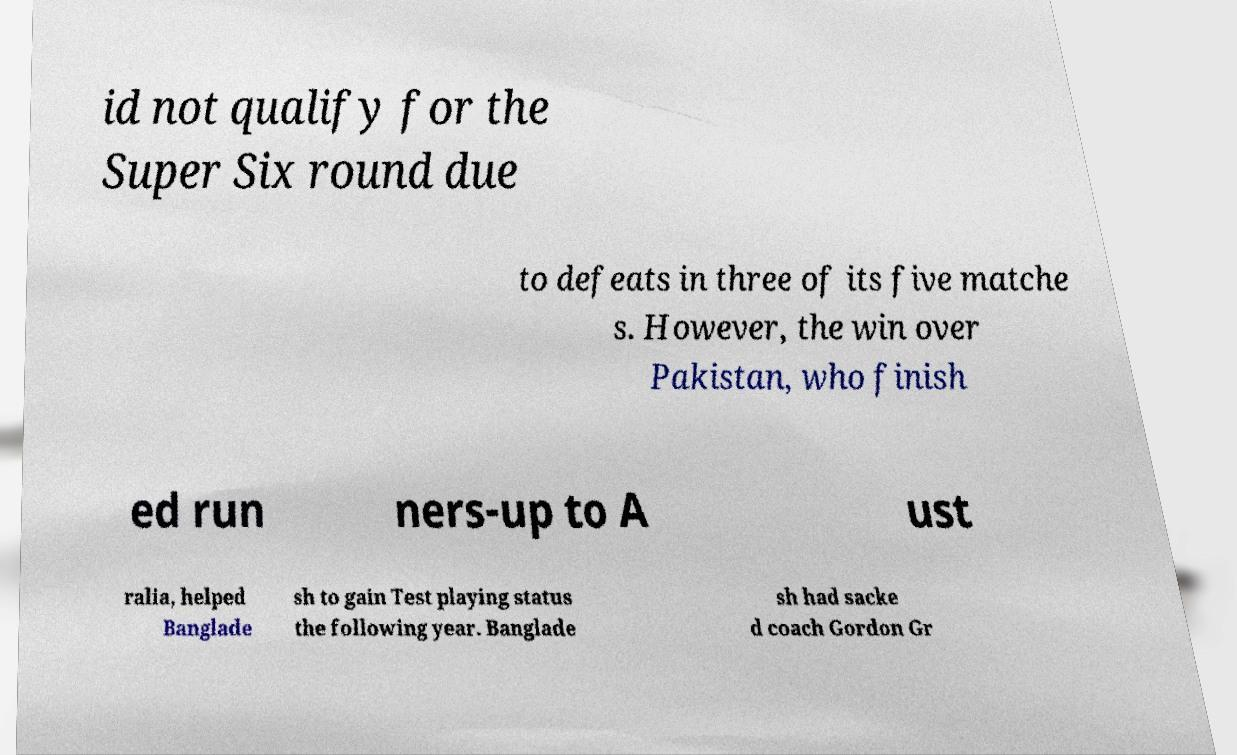Please identify and transcribe the text found in this image. id not qualify for the Super Six round due to defeats in three of its five matche s. However, the win over Pakistan, who finish ed run ners-up to A ust ralia, helped Banglade sh to gain Test playing status the following year. Banglade sh had sacke d coach Gordon Gr 